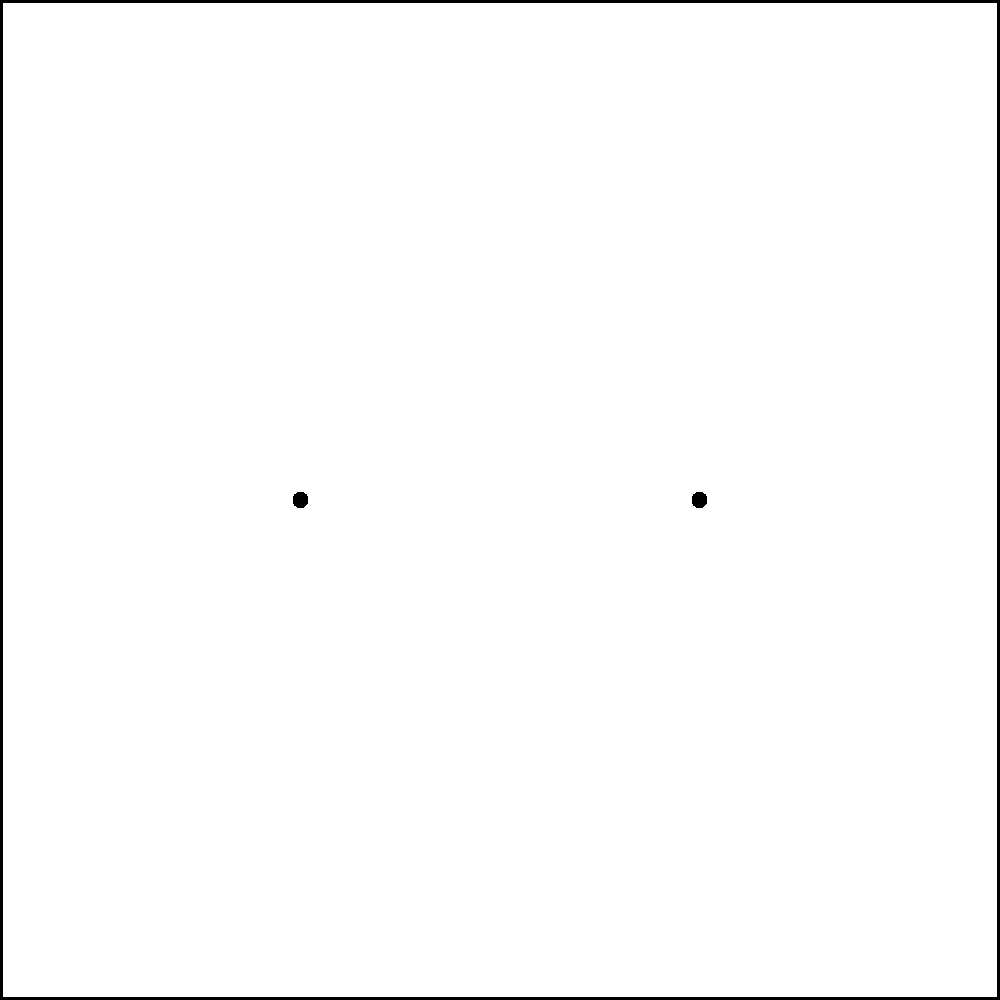In a ripple tank experiment designed to demonstrate wave interference, two point sources S1 and S2 are set up as shown in the diagram. The resulting interference pattern is visible, with areas of constructive (C) and destructive (D) interference clearly marked. As the school principal, you're assessing this experiment for its educational value. If the wavelength of the waves produced by both sources is 2 cm, what is the path difference between waves from S1 and S2 at the first constructive interference point above the central line? To solve this problem, we'll follow these steps:

1) In a two-point source interference pattern, constructive interference occurs when the path difference is an integer multiple of the wavelength:

   $$\Delta r = n\lambda$$

   where $\Delta r$ is the path difference, $n$ is an integer, and $\lambda$ is the wavelength.

2) The first constructive interference point above the central line corresponds to $n = 1$.

3) We're given that the wavelength $\lambda = 2$ cm.

4) Substituting these values into the equation:

   $$\Delta r = 1 \cdot 2 \text{ cm} = 2 \text{ cm}$$

5) This means that at the first constructive interference point above the central line, the waves from S1 have traveled 2 cm farther than the waves from S2 (or vice versa).

This concept is crucial for understanding how waves interact and form interference patterns, which is a fundamental principle in many physics applications, including optics and acoustics.
Answer: 2 cm 